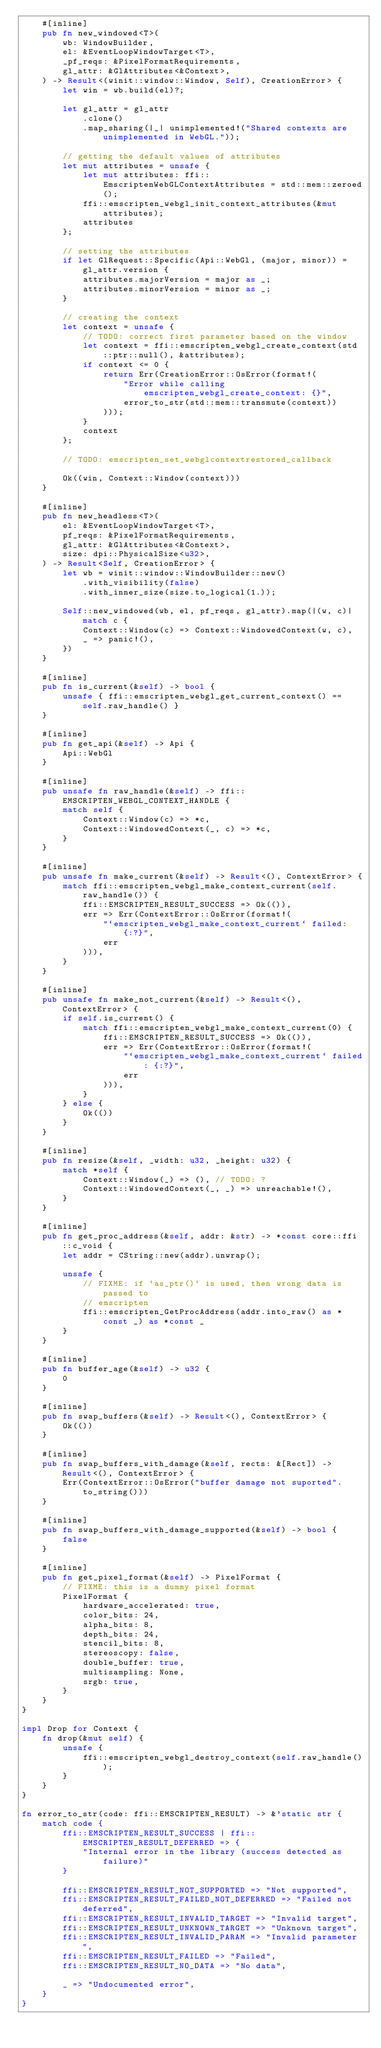Convert code to text. <code><loc_0><loc_0><loc_500><loc_500><_Rust_>    #[inline]
    pub fn new_windowed<T>(
        wb: WindowBuilder,
        el: &EventLoopWindowTarget<T>,
        _pf_reqs: &PixelFormatRequirements,
        gl_attr: &GlAttributes<&Context>,
    ) -> Result<(winit::window::Window, Self), CreationError> {
        let win = wb.build(el)?;

        let gl_attr = gl_attr
            .clone()
            .map_sharing(|_| unimplemented!("Shared contexts are unimplemented in WebGL."));

        // getting the default values of attributes
        let mut attributes = unsafe {
            let mut attributes: ffi::EmscriptenWebGLContextAttributes = std::mem::zeroed();
            ffi::emscripten_webgl_init_context_attributes(&mut attributes);
            attributes
        };

        // setting the attributes
        if let GlRequest::Specific(Api::WebGl, (major, minor)) = gl_attr.version {
            attributes.majorVersion = major as _;
            attributes.minorVersion = minor as _;
        }

        // creating the context
        let context = unsafe {
            // TODO: correct first parameter based on the window
            let context = ffi::emscripten_webgl_create_context(std::ptr::null(), &attributes);
            if context <= 0 {
                return Err(CreationError::OsError(format!(
                    "Error while calling emscripten_webgl_create_context: {}",
                    error_to_str(std::mem::transmute(context))
                )));
            }
            context
        };

        // TODO: emscripten_set_webglcontextrestored_callback

        Ok((win, Context::Window(context)))
    }

    #[inline]
    pub fn new_headless<T>(
        el: &EventLoopWindowTarget<T>,
        pf_reqs: &PixelFormatRequirements,
        gl_attr: &GlAttributes<&Context>,
        size: dpi::PhysicalSize<u32>,
    ) -> Result<Self, CreationError> {
        let wb = winit::window::WindowBuilder::new()
            .with_visibility(false)
            .with_inner_size(size.to_logical(1.));

        Self::new_windowed(wb, el, pf_reqs, gl_attr).map(|(w, c)| match c {
            Context::Window(c) => Context::WindowedContext(w, c),
            _ => panic!(),
        })
    }

    #[inline]
    pub fn is_current(&self) -> bool {
        unsafe { ffi::emscripten_webgl_get_current_context() == self.raw_handle() }
    }

    #[inline]
    pub fn get_api(&self) -> Api {
        Api::WebGl
    }

    #[inline]
    pub unsafe fn raw_handle(&self) -> ffi::EMSCRIPTEN_WEBGL_CONTEXT_HANDLE {
        match self {
            Context::Window(c) => *c,
            Context::WindowedContext(_, c) => *c,
        }
    }

    #[inline]
    pub unsafe fn make_current(&self) -> Result<(), ContextError> {
        match ffi::emscripten_webgl_make_context_current(self.raw_handle()) {
            ffi::EMSCRIPTEN_RESULT_SUCCESS => Ok(()),
            err => Err(ContextError::OsError(format!(
                "`emscripten_webgl_make_context_current` failed: {:?}",
                err
            ))),
        }
    }

    #[inline]
    pub unsafe fn make_not_current(&self) -> Result<(), ContextError> {
        if self.is_current() {
            match ffi::emscripten_webgl_make_context_current(0) {
                ffi::EMSCRIPTEN_RESULT_SUCCESS => Ok(()),
                err => Err(ContextError::OsError(format!(
                    "`emscripten_webgl_make_context_current` failed: {:?}",
                    err
                ))),
            }
        } else {
            Ok(())
        }
    }

    #[inline]
    pub fn resize(&self, _width: u32, _height: u32) {
        match *self {
            Context::Window(_) => (), // TODO: ?
            Context::WindowedContext(_, _) => unreachable!(),
        }
    }

    #[inline]
    pub fn get_proc_address(&self, addr: &str) -> *const core::ffi::c_void {
        let addr = CString::new(addr).unwrap();

        unsafe {
            // FIXME: if `as_ptr()` is used, then wrong data is passed to
            // emscripten
            ffi::emscripten_GetProcAddress(addr.into_raw() as *const _) as *const _
        }
    }

    #[inline]
    pub fn buffer_age(&self) -> u32 {
        0
    }

    #[inline]
    pub fn swap_buffers(&self) -> Result<(), ContextError> {
        Ok(())
    }

    #[inline]
    pub fn swap_buffers_with_damage(&self, rects: &[Rect]) -> Result<(), ContextError> {
        Err(ContextError::OsError("buffer damage not suported".to_string()))
    }

    #[inline]
    pub fn swap_buffers_with_damage_supported(&self) -> bool {
        false
    }

    #[inline]
    pub fn get_pixel_format(&self) -> PixelFormat {
        // FIXME: this is a dummy pixel format
        PixelFormat {
            hardware_accelerated: true,
            color_bits: 24,
            alpha_bits: 8,
            depth_bits: 24,
            stencil_bits: 8,
            stereoscopy: false,
            double_buffer: true,
            multisampling: None,
            srgb: true,
        }
    }
}

impl Drop for Context {
    fn drop(&mut self) {
        unsafe {
            ffi::emscripten_webgl_destroy_context(self.raw_handle());
        }
    }
}

fn error_to_str(code: ffi::EMSCRIPTEN_RESULT) -> &'static str {
    match code {
        ffi::EMSCRIPTEN_RESULT_SUCCESS | ffi::EMSCRIPTEN_RESULT_DEFERRED => {
            "Internal error in the library (success detected as failure)"
        }

        ffi::EMSCRIPTEN_RESULT_NOT_SUPPORTED => "Not supported",
        ffi::EMSCRIPTEN_RESULT_FAILED_NOT_DEFERRED => "Failed not deferred",
        ffi::EMSCRIPTEN_RESULT_INVALID_TARGET => "Invalid target",
        ffi::EMSCRIPTEN_RESULT_UNKNOWN_TARGET => "Unknown target",
        ffi::EMSCRIPTEN_RESULT_INVALID_PARAM => "Invalid parameter",
        ffi::EMSCRIPTEN_RESULT_FAILED => "Failed",
        ffi::EMSCRIPTEN_RESULT_NO_DATA => "No data",

        _ => "Undocumented error",
    }
}
</code> 